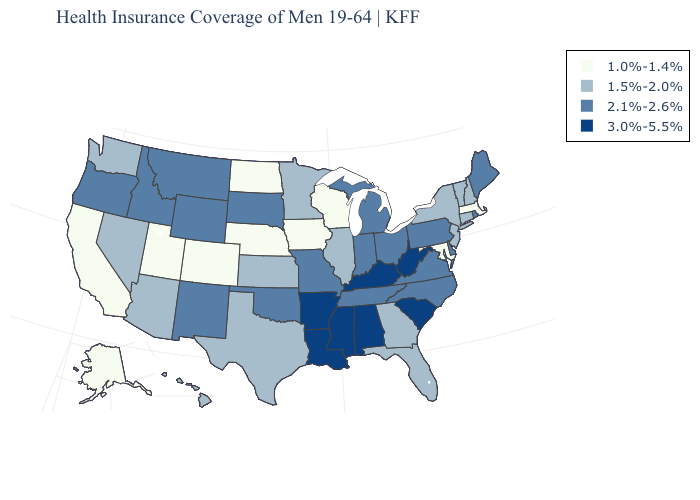Does Ohio have the highest value in the MidWest?
Short answer required. Yes. Does Washington have the lowest value in the West?
Be succinct. No. Does Ohio have the highest value in the MidWest?
Give a very brief answer. Yes. Among the states that border Connecticut , does Massachusetts have the lowest value?
Be succinct. Yes. What is the value of New Hampshire?
Short answer required. 1.5%-2.0%. Name the states that have a value in the range 1.0%-1.4%?
Quick response, please. Alaska, California, Colorado, Iowa, Maryland, Massachusetts, Nebraska, North Dakota, Utah, Wisconsin. Name the states that have a value in the range 1.0%-1.4%?
Short answer required. Alaska, California, Colorado, Iowa, Maryland, Massachusetts, Nebraska, North Dakota, Utah, Wisconsin. Name the states that have a value in the range 3.0%-5.5%?
Quick response, please. Alabama, Arkansas, Kentucky, Louisiana, Mississippi, South Carolina, West Virginia. Name the states that have a value in the range 1.5%-2.0%?
Write a very short answer. Arizona, Connecticut, Florida, Georgia, Hawaii, Illinois, Kansas, Minnesota, Nevada, New Hampshire, New Jersey, New York, Texas, Vermont, Washington. Does South Carolina have a lower value than Arizona?
Write a very short answer. No. Is the legend a continuous bar?
Answer briefly. No. Does Ohio have the lowest value in the MidWest?
Quick response, please. No. What is the lowest value in the USA?
Give a very brief answer. 1.0%-1.4%. What is the highest value in states that border Washington?
Concise answer only. 2.1%-2.6%. What is the lowest value in states that border Delaware?
Concise answer only. 1.0%-1.4%. 